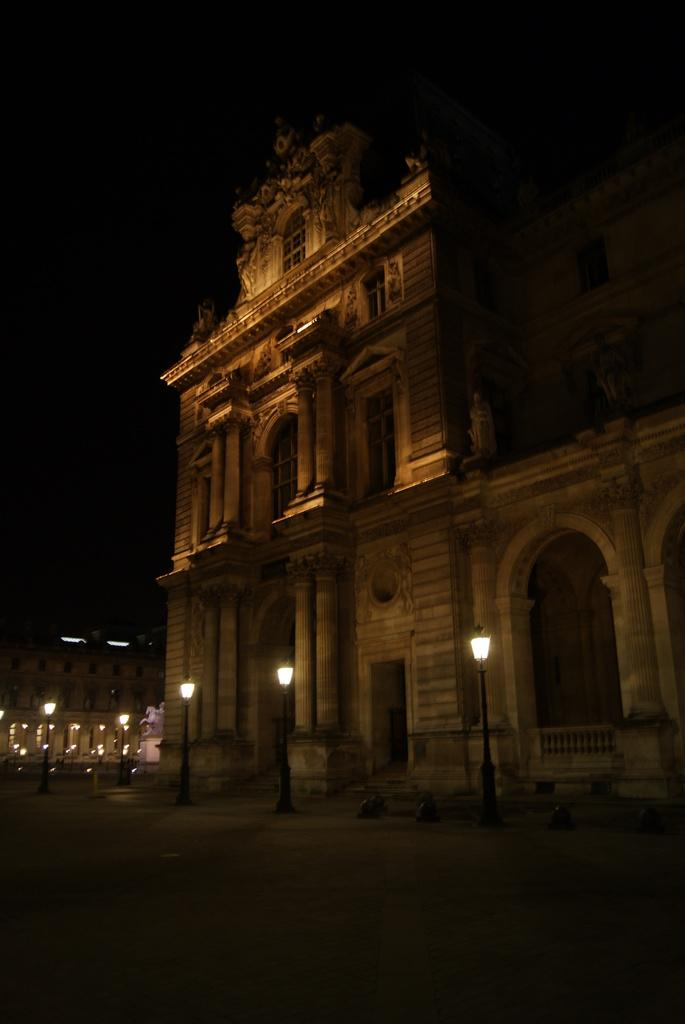What type of structures can be seen in the image? There are buildings in the image. Is there any specific landmark or feature in the image? Yes, there is a monument in the image. What can be seen illuminating the area in front of the buildings? Street lights are visible in front of the buildings. What is at the bottom of the image? There is a road at the bottom of the image. Where is the throne located in the image? There is no throne present in the image. What type of treatment is being administered to the monument in the image? There is no treatment being administered to the monument in the image; it is a stationary structure. 